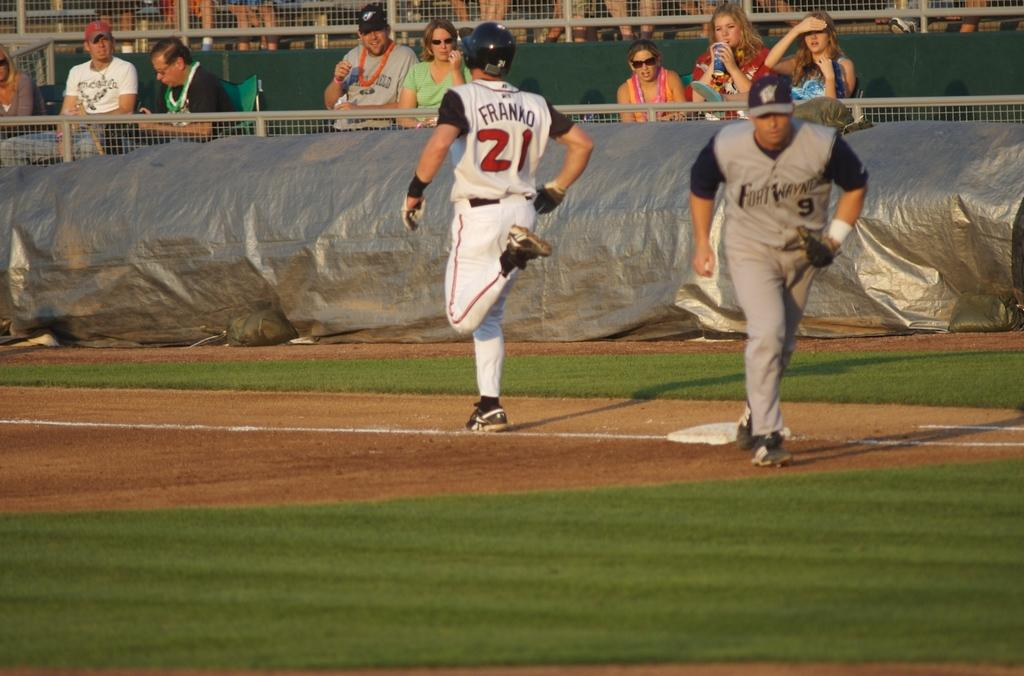<image>
Present a compact description of the photo's key features. 2 baseball players on the field with one that has the number 21 